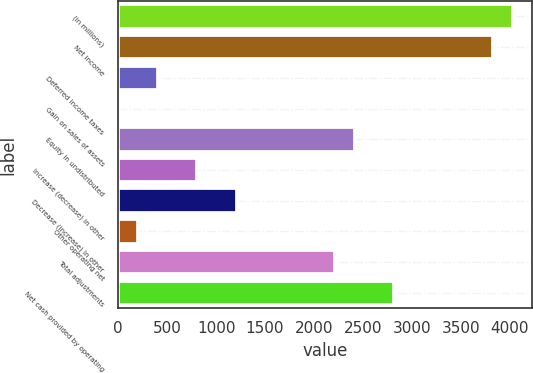<chart> <loc_0><loc_0><loc_500><loc_500><bar_chart><fcel>(in millions)<fcel>Net income<fcel>Deferred income taxes<fcel>Gain on sales of assets<fcel>Equity in undistributed<fcel>Increase (decrease) in other<fcel>Decrease (increase) in other<fcel>Other operating net<fcel>Total adjustments<fcel>Net cash provided by operating<nl><fcel>4029<fcel>3827.7<fcel>405.6<fcel>3<fcel>2418.6<fcel>808.2<fcel>1210.8<fcel>204.3<fcel>2217.3<fcel>2821.2<nl></chart> 